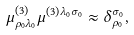<formula> <loc_0><loc_0><loc_500><loc_500>\mu _ { \rho _ { 0 } \lambda _ { 0 } } ^ { \left ( 3 \right ) } \mu ^ { \left ( 3 \right ) \lambda _ { 0 } \sigma _ { 0 } } \approx \delta _ { \rho _ { 0 } } ^ { \sigma _ { 0 } } ,</formula> 